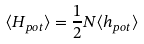Convert formula to latex. <formula><loc_0><loc_0><loc_500><loc_500>\langle H _ { p o t } \rangle = \frac { 1 } { 2 } N \langle h _ { p o t } \rangle</formula> 